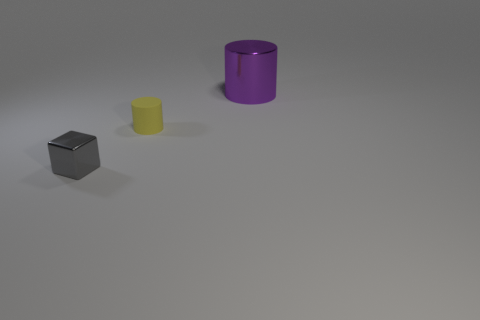What is the shape of the big shiny thing?
Ensure brevity in your answer.  Cylinder. There is a small yellow thing; is it the same shape as the metallic thing that is to the right of the cube?
Keep it short and to the point. Yes. Is the shape of the metal thing in front of the large cylinder the same as  the tiny matte object?
Provide a short and direct response. No. What number of shiny things are both behind the yellow thing and to the left of the purple metal thing?
Your answer should be very brief. 0. How many other things are there of the same size as the matte cylinder?
Provide a short and direct response. 1. Are there the same number of matte cylinders that are behind the big shiny cylinder and tiny gray blocks?
Provide a succinct answer. No. There is a shiny thing that is behind the metallic cube; is it the same color as the thing in front of the small yellow rubber cylinder?
Keep it short and to the point. No. What material is the object that is both left of the big object and right of the gray metallic object?
Offer a terse response. Rubber. What is the color of the tiny matte cylinder?
Your answer should be very brief. Yellow. How many other objects are there of the same shape as the tiny gray metallic thing?
Ensure brevity in your answer.  0. 